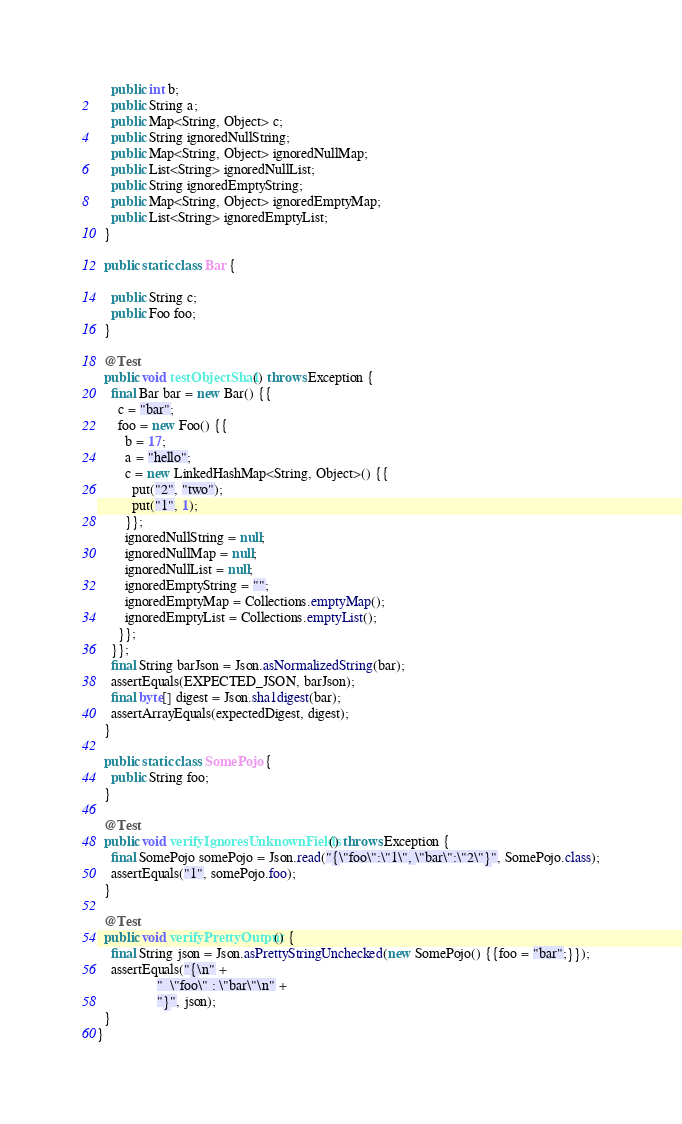Convert code to text. <code><loc_0><loc_0><loc_500><loc_500><_Java_>    public int b;
    public String a;
    public Map<String, Object> c;
    public String ignoredNullString;
    public Map<String, Object> ignoredNullMap;
    public List<String> ignoredNullList;
    public String ignoredEmptyString;
    public Map<String, Object> ignoredEmptyMap;
    public List<String> ignoredEmptyList;
  }

  public static class Bar {

    public String c;
    public Foo foo;
  }

  @Test
  public void testObjectSha1() throws Exception {
    final Bar bar = new Bar() {{
      c = "bar";
      foo = new Foo() {{
        b = 17;
        a = "hello";
        c = new LinkedHashMap<String, Object>() {{
          put("2", "two");
          put("1", 1);
        }};
        ignoredNullString = null;
        ignoredNullMap = null;
        ignoredNullList = null;
        ignoredEmptyString = "";
        ignoredEmptyMap = Collections.emptyMap();
        ignoredEmptyList = Collections.emptyList();
      }};
    }};
    final String barJson = Json.asNormalizedString(bar);
    assertEquals(EXPECTED_JSON, barJson);
    final byte[] digest = Json.sha1digest(bar);
    assertArrayEquals(expectedDigest, digest);
  }

  public static class SomePojo {
    public String foo;
  }

  @Test
  public void verifyIgnoresUnknownFields() throws Exception {
    final SomePojo somePojo = Json.read("{\"foo\":\"1\", \"bar\":\"2\"}", SomePojo.class);
    assertEquals("1", somePojo.foo);
  }

  @Test
  public void verifyPrettyOutput() {
    final String json = Json.asPrettyStringUnchecked(new SomePojo() {{foo = "bar";}});
    assertEquals("{\n" +
                 "  \"foo\" : \"bar\"\n" +
                 "}", json);
  }
}
</code> 